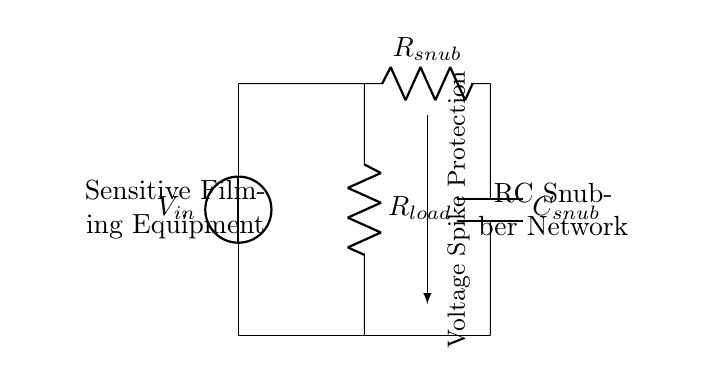What is the purpose of the RC snubber network? The RC snubber network is designed to absorb voltage spikes, protecting the sensitive filming equipment from sudden changes in voltage. This is particularly important in environments where equipment may be exposed to electrical noise or surges.
Answer: Absorb voltage spikes What are the components of the snubber network? The snubber network consists of a resistor labeled R snub and a capacitor labeled C snub. These components work together to dampen voltage spikes that could affect equipment performance.
Answer: Resistor and capacitor What is the connection point for the sensitive filming equipment? The sensitive filming equipment is connected to the circuit at the bottom left corner where the voltage drops back to the power supply after passing through the load and the snubber network.
Answer: Bottom left corner How many resistors are there in the circuit? There are two resistors in the circuit: one is R load and the other is R snub. Each serves a different purpose in the circuit, providing load and voltage spike protection, respectively.
Answer: Two What is the role of the capacitor in this circuit? The capacitor in the RC snubber network helps to absorb energy from voltage spikes, thus reducing the amplitude of the spike before it reaches the sensitive filming equipment. This ensures the equipment is protected from potentially damaging over-voltages.
Answer: Absorb energy from spikes What does the arrow indicate in the circuit? The arrow indicates the direction of voltage spike protection facilitated by the snubber network, showing how it helps divert unwanted electrical disturbances away from the sensitive filming equipment.
Answer: Voltage spike protection What is the voltage source in this circuit? The voltage source is labeled V in, which represents the input voltage provided to the circuit that supplies power to the load and the snubber network.
Answer: V in 